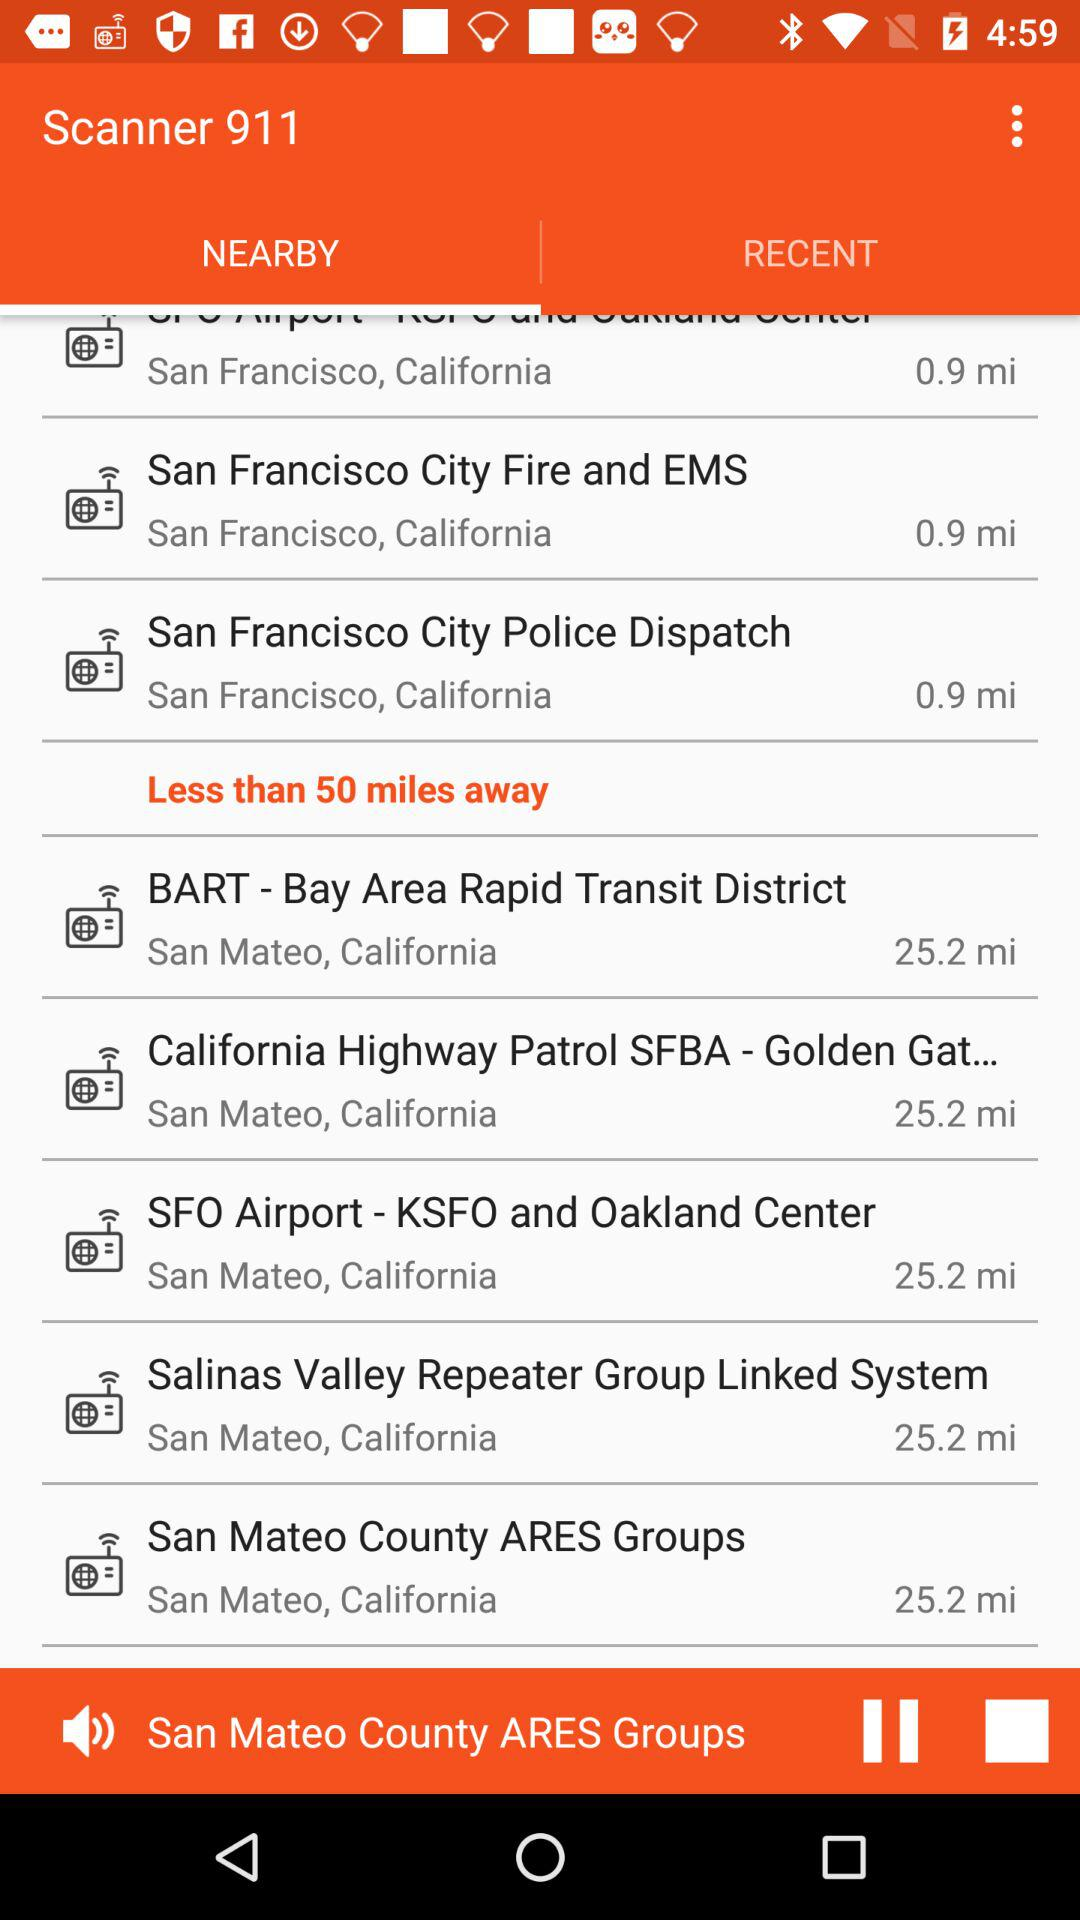How far away are San Francisco City Fire and EMS? The San Francisco City Fire and EMS are 0.9 miles away. 